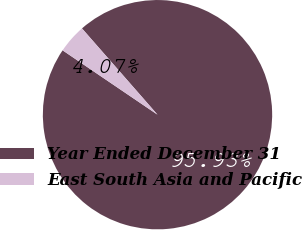Convert chart to OTSL. <chart><loc_0><loc_0><loc_500><loc_500><pie_chart><fcel>Year Ended December 31<fcel>East South Asia and Pacific<nl><fcel>95.93%<fcel>4.07%<nl></chart> 